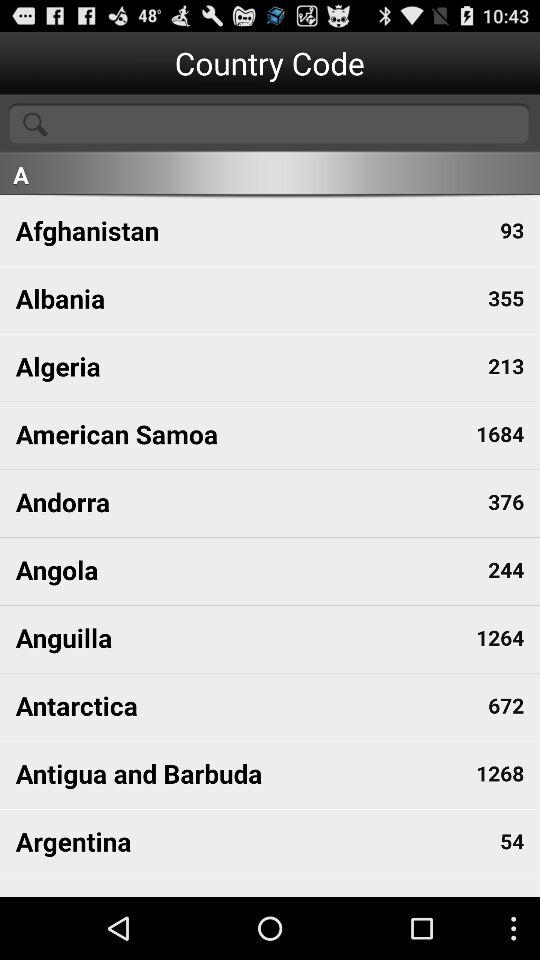Which country has code 54? The country is Argentina. 